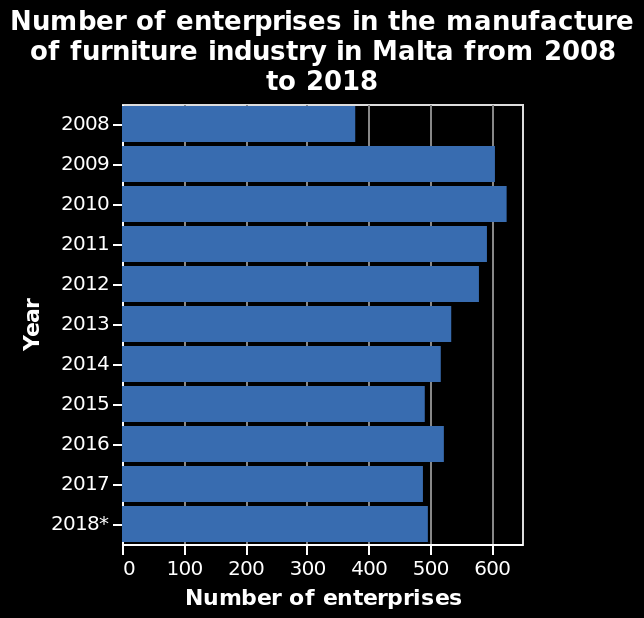<image>
What is the title of this bar plot? "Number of enterprises in the manufacture of furniture industry in Malta from 2008 to 2018." 